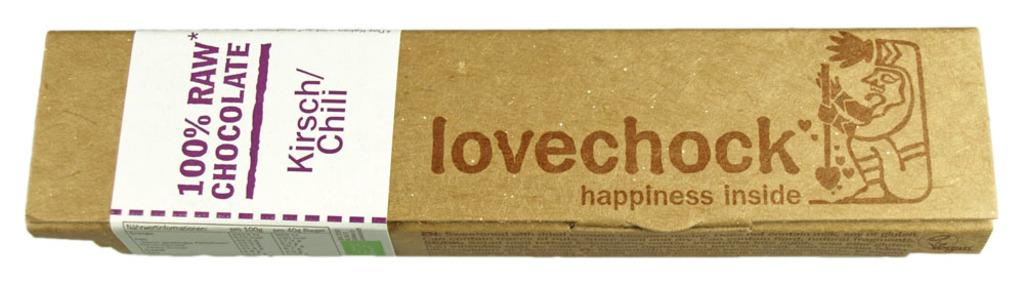<image>
Offer a succinct explanation of the picture presented. a box of 100% raw chocolate kirsch/chilli by lovechock 